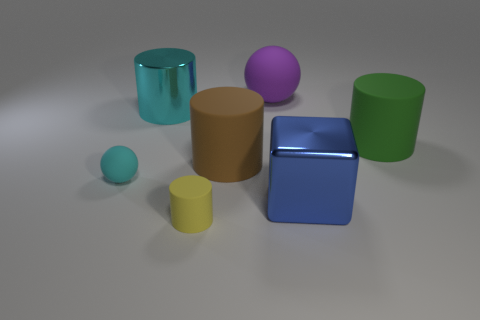Add 3 tiny blue rubber blocks. How many objects exist? 10 Subtract all cylinders. How many objects are left? 3 Add 6 yellow cylinders. How many yellow cylinders exist? 7 Subtract 0 green blocks. How many objects are left? 7 Subtract all green rubber cylinders. Subtract all small purple matte cylinders. How many objects are left? 6 Add 6 cyan shiny cylinders. How many cyan shiny cylinders are left? 7 